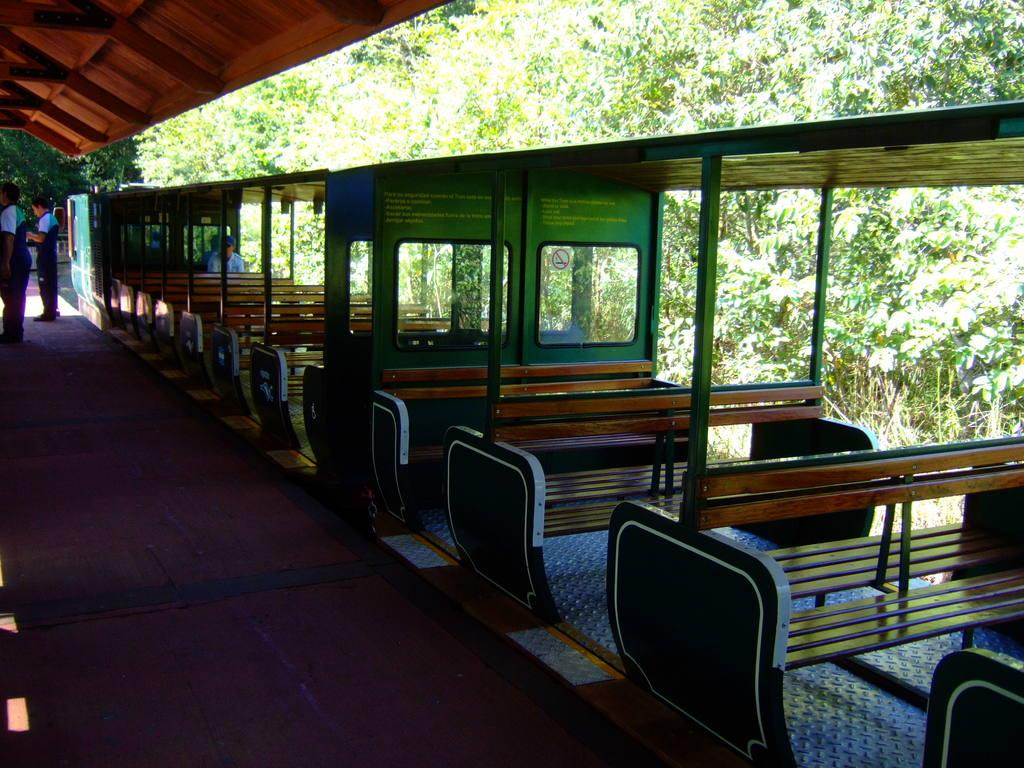What type of seating is visible in the image? There are benches in the image. Who is using the benches in the image? A person is sitting on the benches. What are the people on the floor doing? There are people standing on the floor. What type of structure can be seen in the image? There is a shed in the image. What type of vegetation is present in the image? Trees are present in the image. How many sheep are visible on the canvas in the image? There is no canvas or sheep present in the image. 